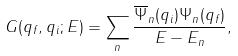Convert formula to latex. <formula><loc_0><loc_0><loc_500><loc_500>G ( q _ { f } , q _ { i } ; E ) = \sum _ { n } \frac { \overline { \Psi } _ { n } ( q _ { i } ) \Psi _ { n } ( q _ { f } ) } { E - E _ { n } } ,</formula> 